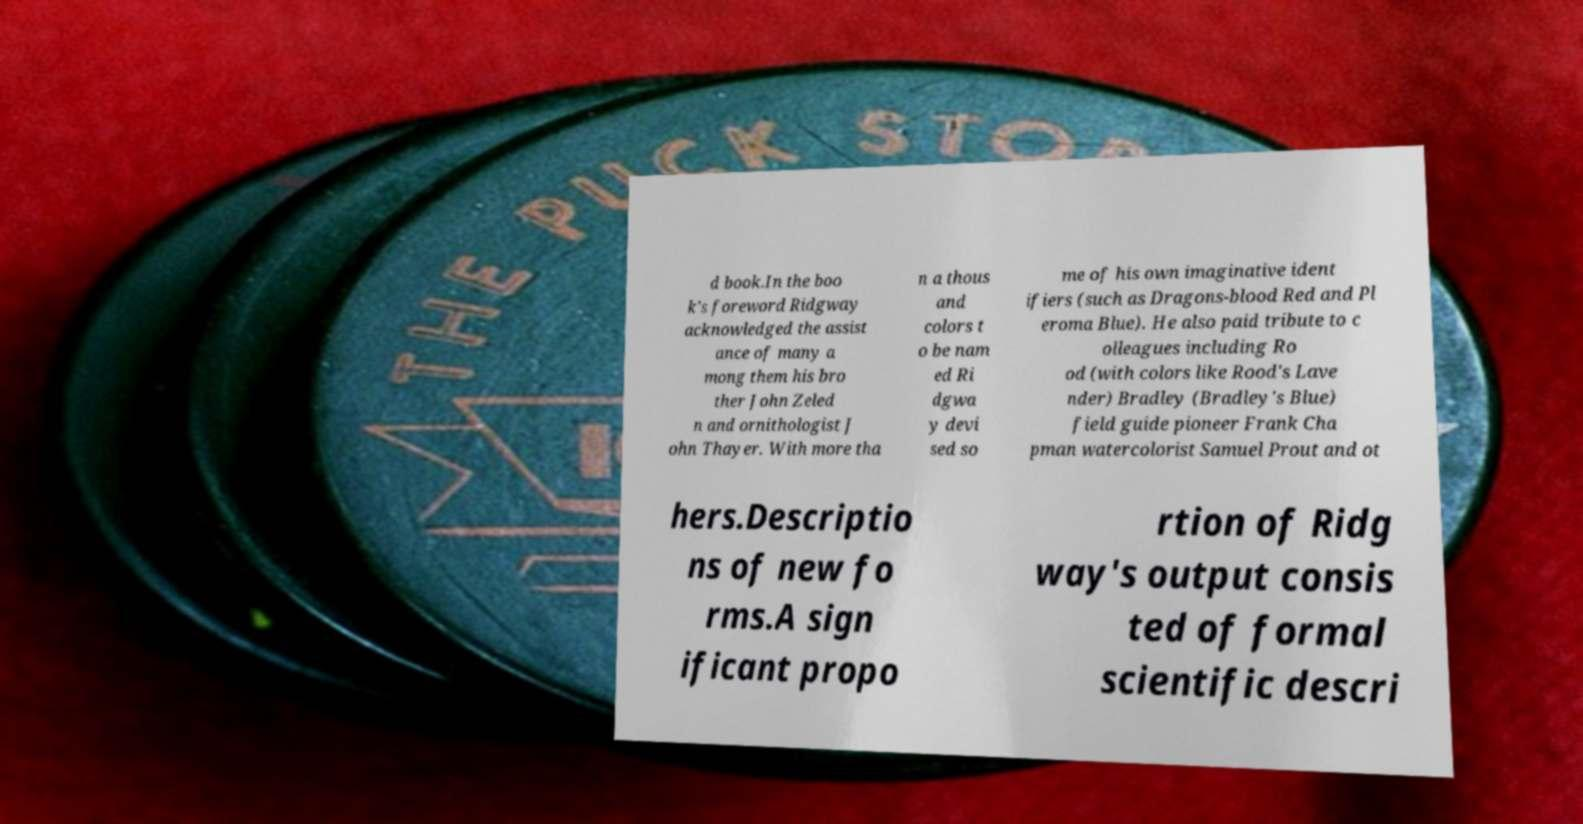Could you extract and type out the text from this image? d book.In the boo k's foreword Ridgway acknowledged the assist ance of many a mong them his bro ther John Zeled n and ornithologist J ohn Thayer. With more tha n a thous and colors t o be nam ed Ri dgwa y devi sed so me of his own imaginative ident ifiers (such as Dragons-blood Red and Pl eroma Blue). He also paid tribute to c olleagues including Ro od (with colors like Rood's Lave nder) Bradley (Bradley's Blue) field guide pioneer Frank Cha pman watercolorist Samuel Prout and ot hers.Descriptio ns of new fo rms.A sign ificant propo rtion of Ridg way's output consis ted of formal scientific descri 